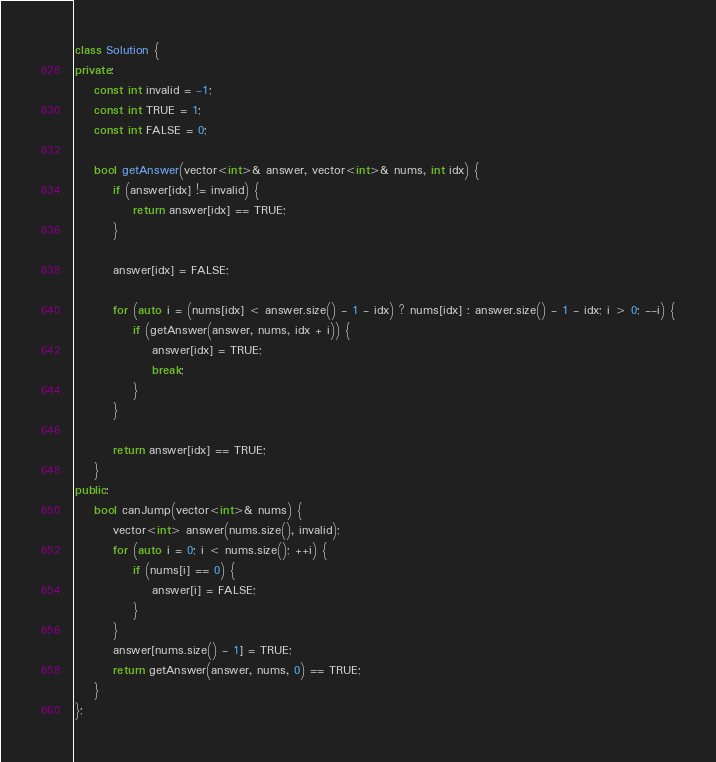<code> <loc_0><loc_0><loc_500><loc_500><_C++_>class Solution {
private:
    const int invalid = -1;
    const int TRUE = 1;
    const int FALSE = 0;

    bool getAnswer(vector<int>& answer, vector<int>& nums, int idx) {
        if (answer[idx] != invalid) {
            return answer[idx] == TRUE;
        }

        answer[idx] = FALSE;

        for (auto i = (nums[idx] < answer.size() - 1 - idx) ? nums[idx] : answer.size() - 1 - idx; i > 0; --i) {
            if (getAnswer(answer, nums, idx + i)) {
                answer[idx] = TRUE;
                break;
            }
        }

        return answer[idx] == TRUE;
    }
public:
    bool canJump(vector<int>& nums) {
        vector<int> answer(nums.size(), invalid);
        for (auto i = 0; i < nums.size(); ++i) {
            if (nums[i] == 0) {
                answer[i] = FALSE;
            }
        }
        answer[nums.size() - 1] = TRUE;
        return getAnswer(answer, nums, 0) == TRUE;
    }
};
</code> 